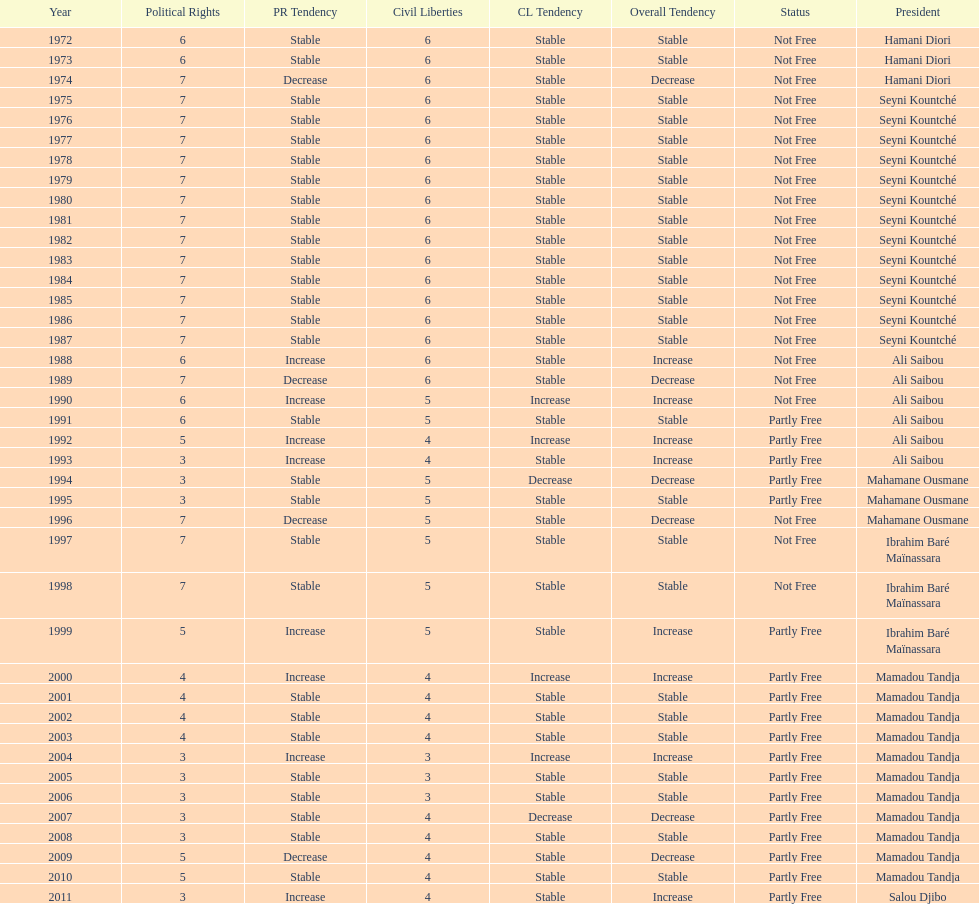Who is the next president listed after hamani diori in the year 1974? Seyni Kountché. 